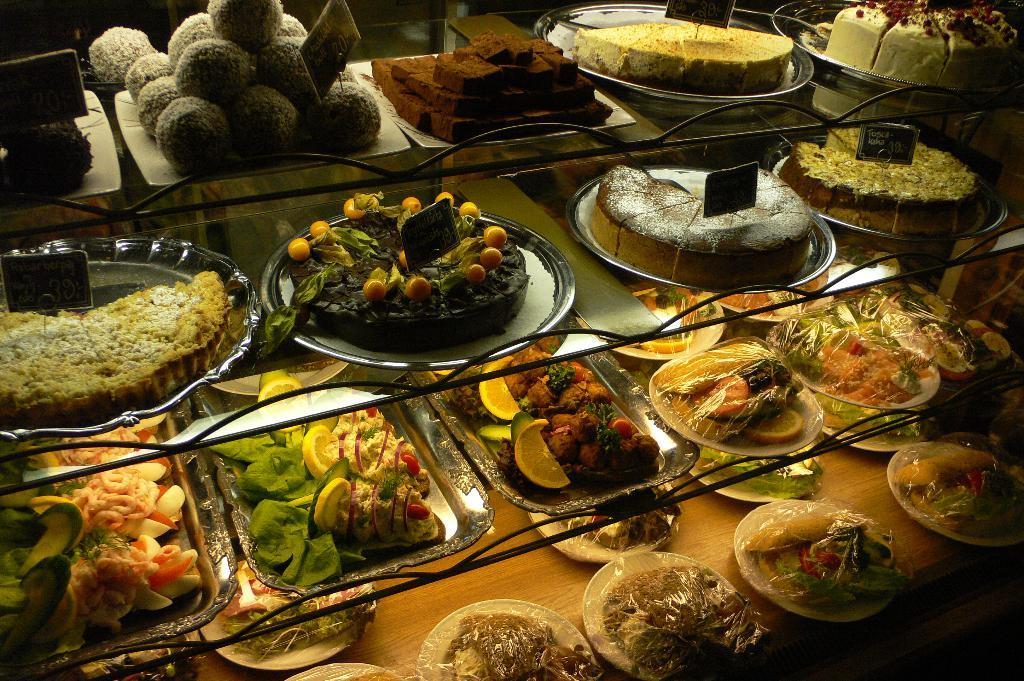What is the main subject of the image? The main subject of the image is food. Can you describe the appearance of the food? The food has multiple colors. Where is the food located in the image? The food is on a tray. What is the tray placed on? The trays are on a glass rack. What type of dirt can be seen on the food in the image? There is no dirt present on the food in the image. How does the food talk to the person in the image? The food does not talk in the image, as it is not a living being capable of speech. 